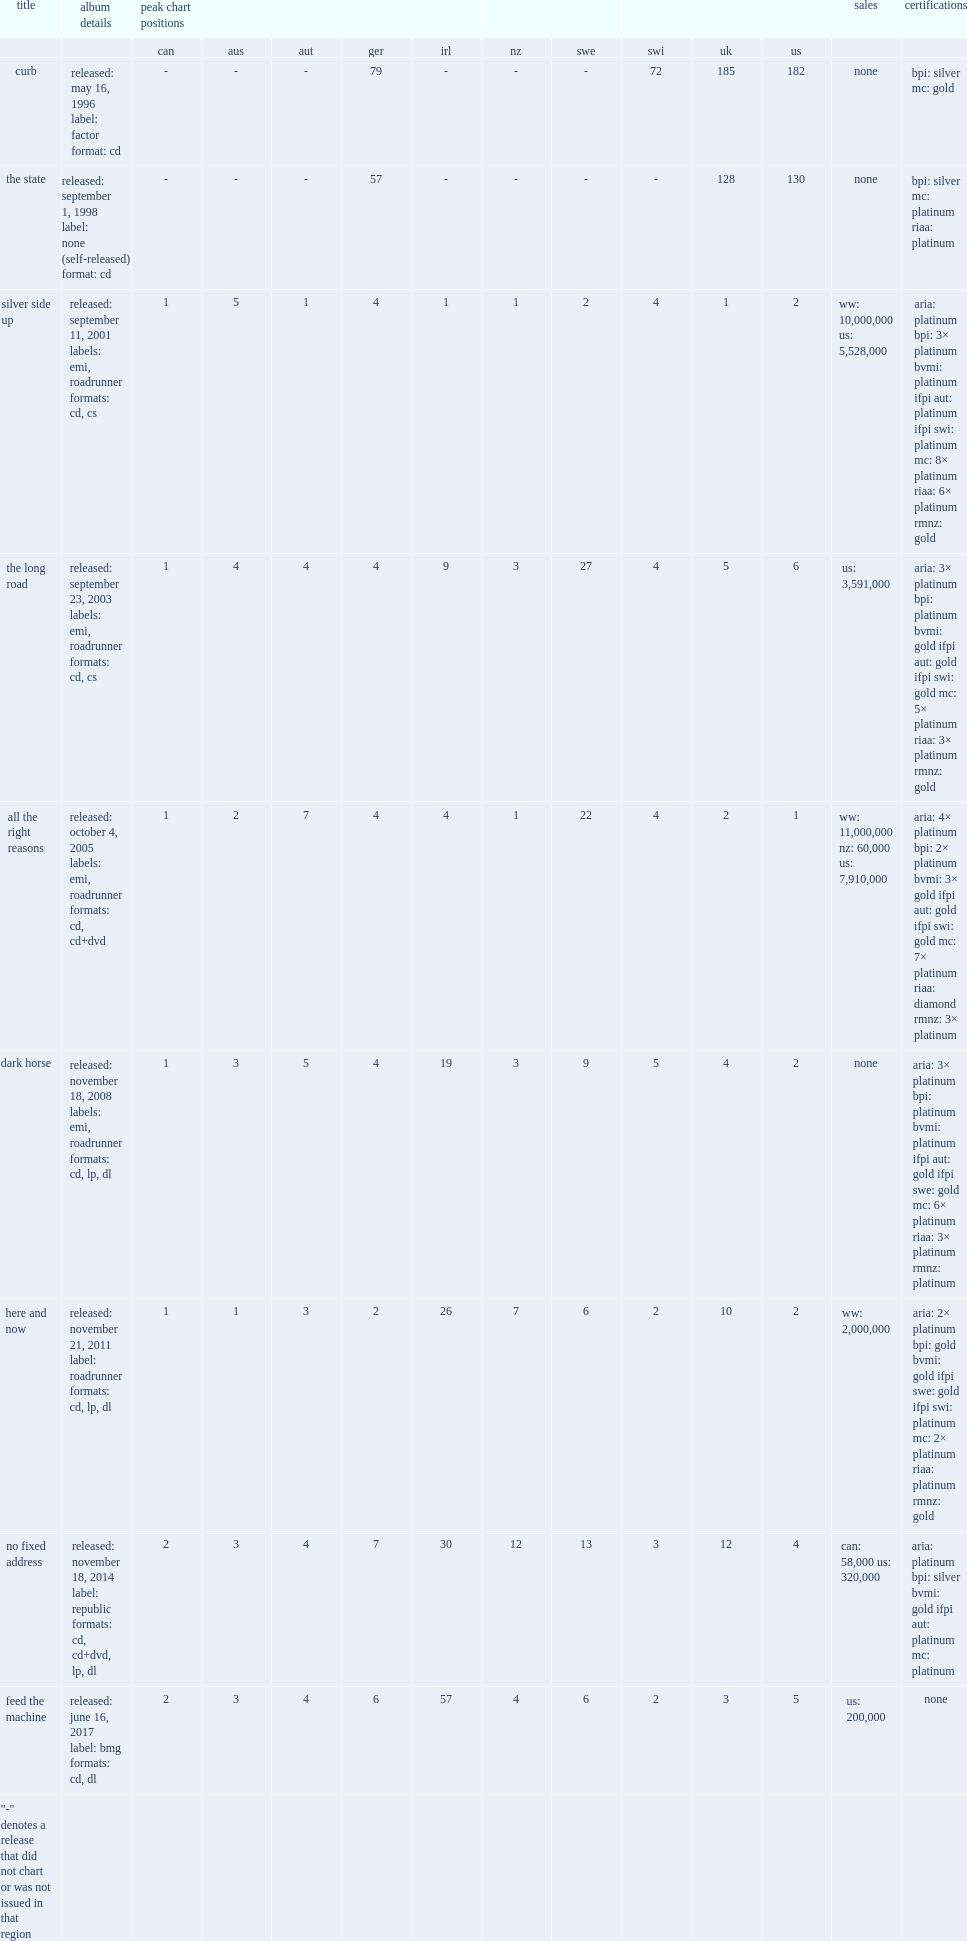What was the peak chart position on the us of the state? 130.0. 